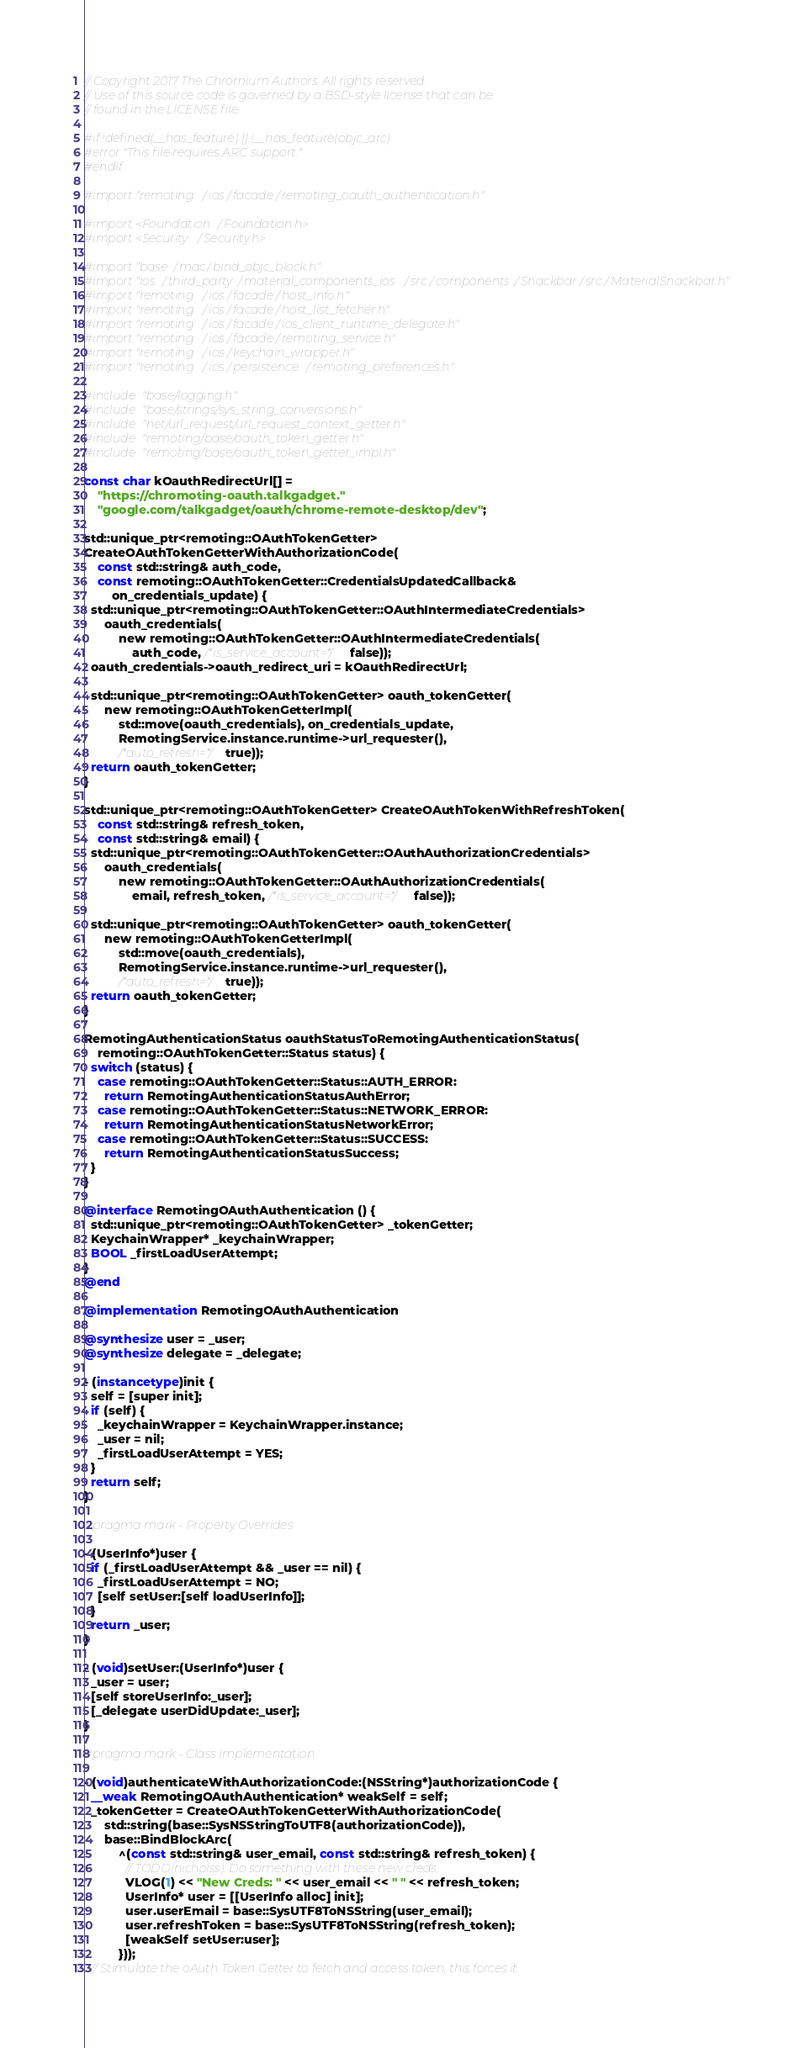<code> <loc_0><loc_0><loc_500><loc_500><_ObjectiveC_>// Copyright 2017 The Chromium Authors. All rights reserved.
// Use of this source code is governed by a BSD-style license that can be
// found in the LICENSE file.

#if !defined(__has_feature) || !__has_feature(objc_arc)
#error "This file requires ARC support."
#endif

#import "remoting/ios/facade/remoting_oauth_authentication.h"

#import <Foundation/Foundation.h>
#import <Security/Security.h>

#import "base/mac/bind_objc_block.h"
#import "ios/third_party/material_components_ios/src/components/Snackbar/src/MaterialSnackbar.h"
#import "remoting/ios/facade/host_info.h"
#import "remoting/ios/facade/host_list_fetcher.h"
#import "remoting/ios/facade/ios_client_runtime_delegate.h"
#import "remoting/ios/facade/remoting_service.h"
#import "remoting/ios/keychain_wrapper.h"
#import "remoting/ios/persistence/remoting_preferences.h"

#include "base/logging.h"
#include "base/strings/sys_string_conversions.h"
#include "net/url_request/url_request_context_getter.h"
#include "remoting/base/oauth_token_getter.h"
#include "remoting/base/oauth_token_getter_impl.h"

const char kOauthRedirectUrl[] =
    "https://chromoting-oauth.talkgadget."
    "google.com/talkgadget/oauth/chrome-remote-desktop/dev";

std::unique_ptr<remoting::OAuthTokenGetter>
CreateOAuthTokenGetterWithAuthorizationCode(
    const std::string& auth_code,
    const remoting::OAuthTokenGetter::CredentialsUpdatedCallback&
        on_credentials_update) {
  std::unique_ptr<remoting::OAuthTokenGetter::OAuthIntermediateCredentials>
      oauth_credentials(
          new remoting::OAuthTokenGetter::OAuthIntermediateCredentials(
              auth_code, /*is_service_account=*/false));
  oauth_credentials->oauth_redirect_uri = kOauthRedirectUrl;

  std::unique_ptr<remoting::OAuthTokenGetter> oauth_tokenGetter(
      new remoting::OAuthTokenGetterImpl(
          std::move(oauth_credentials), on_credentials_update,
          RemotingService.instance.runtime->url_requester(),
          /*auto_refresh=*/true));
  return oauth_tokenGetter;
}

std::unique_ptr<remoting::OAuthTokenGetter> CreateOAuthTokenWithRefreshToken(
    const std::string& refresh_token,
    const std::string& email) {
  std::unique_ptr<remoting::OAuthTokenGetter::OAuthAuthorizationCredentials>
      oauth_credentials(
          new remoting::OAuthTokenGetter::OAuthAuthorizationCredentials(
              email, refresh_token, /*is_service_account=*/false));

  std::unique_ptr<remoting::OAuthTokenGetter> oauth_tokenGetter(
      new remoting::OAuthTokenGetterImpl(
          std::move(oauth_credentials),
          RemotingService.instance.runtime->url_requester(),
          /*auto_refresh=*/true));
  return oauth_tokenGetter;
}

RemotingAuthenticationStatus oauthStatusToRemotingAuthenticationStatus(
    remoting::OAuthTokenGetter::Status status) {
  switch (status) {
    case remoting::OAuthTokenGetter::Status::AUTH_ERROR:
      return RemotingAuthenticationStatusAuthError;
    case remoting::OAuthTokenGetter::Status::NETWORK_ERROR:
      return RemotingAuthenticationStatusNetworkError;
    case remoting::OAuthTokenGetter::Status::SUCCESS:
      return RemotingAuthenticationStatusSuccess;
  }
}

@interface RemotingOAuthAuthentication () {
  std::unique_ptr<remoting::OAuthTokenGetter> _tokenGetter;
  KeychainWrapper* _keychainWrapper;
  BOOL _firstLoadUserAttempt;
}
@end

@implementation RemotingOAuthAuthentication

@synthesize user = _user;
@synthesize delegate = _delegate;

- (instancetype)init {
  self = [super init];
  if (self) {
    _keychainWrapper = KeychainWrapper.instance;
    _user = nil;
    _firstLoadUserAttempt = YES;
  }
  return self;
}

#pragma mark - Property Overrides

- (UserInfo*)user {
  if (_firstLoadUserAttempt && _user == nil) {
    _firstLoadUserAttempt = NO;
    [self setUser:[self loadUserInfo]];
  }
  return _user;
}

- (void)setUser:(UserInfo*)user {
  _user = user;
  [self storeUserInfo:_user];
  [_delegate userDidUpdate:_user];
}

#pragma mark - Class Implementation

- (void)authenticateWithAuthorizationCode:(NSString*)authorizationCode {
  __weak RemotingOAuthAuthentication* weakSelf = self;
  _tokenGetter = CreateOAuthTokenGetterWithAuthorizationCode(
      std::string(base::SysNSStringToUTF8(authorizationCode)),
      base::BindBlockArc(
          ^(const std::string& user_email, const std::string& refresh_token) {
            // TODO(nicholss): Do something with these new creds.
            VLOG(1) << "New Creds: " << user_email << " " << refresh_token;
            UserInfo* user = [[UserInfo alloc] init];
            user.userEmail = base::SysUTF8ToNSString(user_email);
            user.refreshToken = base::SysUTF8ToNSString(refresh_token);
            [weakSelf setUser:user];
          }));
  // Stimulate the oAuth Token Getter to fetch and access token, this forces it</code> 